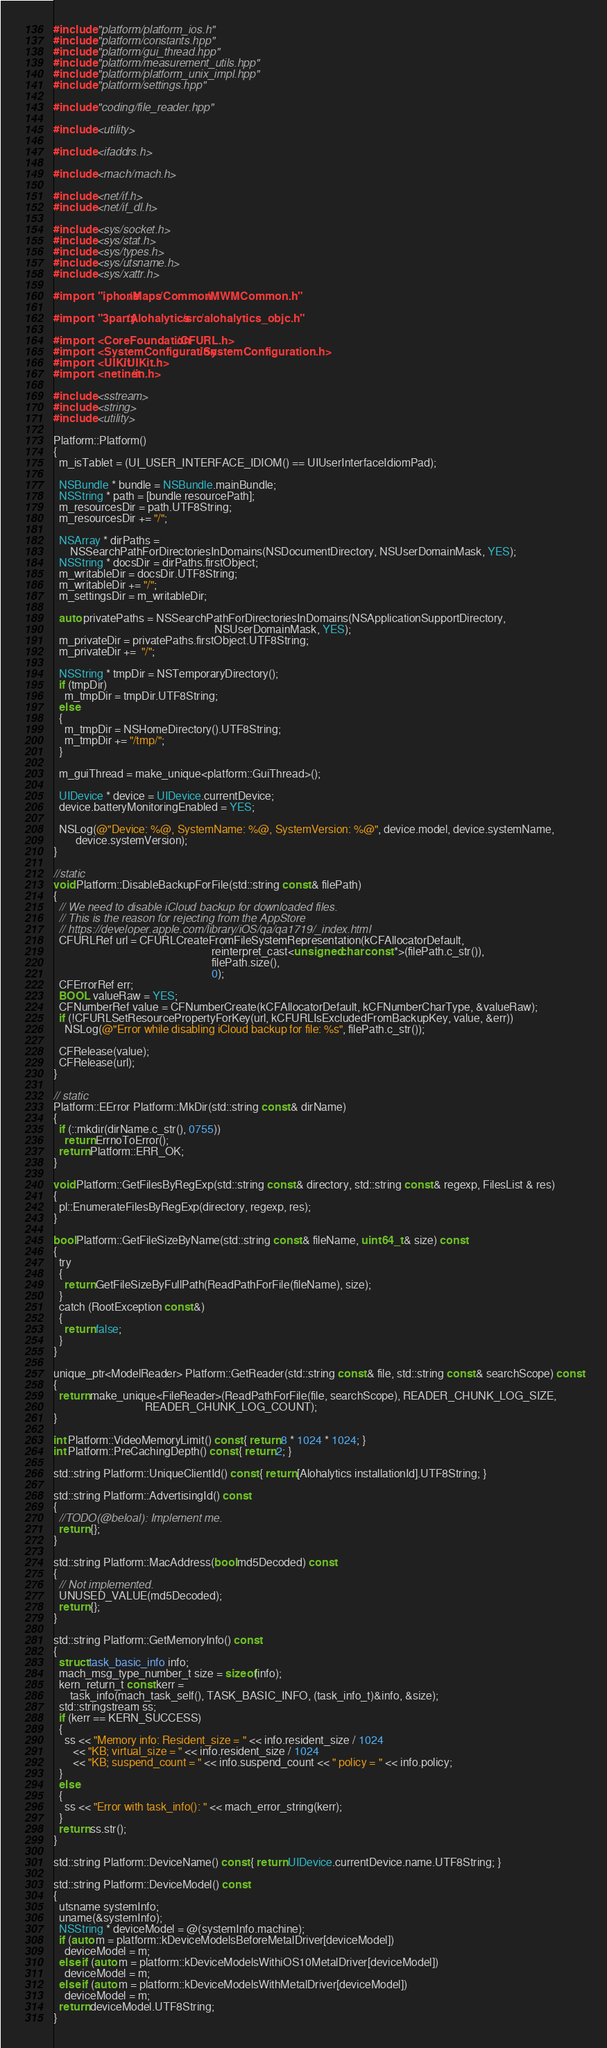Convert code to text. <code><loc_0><loc_0><loc_500><loc_500><_ObjectiveC_>#include "platform/platform_ios.h"
#include "platform/constants.hpp"
#include "platform/gui_thread.hpp"
#include "platform/measurement_utils.hpp"
#include "platform/platform_unix_impl.hpp"
#include "platform/settings.hpp"

#include "coding/file_reader.hpp"

#include <utility>

#include <ifaddrs.h>

#include <mach/mach.h>

#include <net/if.h>
#include <net/if_dl.h>

#include <sys/socket.h>
#include <sys/stat.h>
#include <sys/types.h>
#include <sys/utsname.h>
#include <sys/xattr.h>

#import "iphone/Maps/Common/MWMCommon.h"

#import "3party/Alohalytics/src/alohalytics_objc.h"

#import <CoreFoundation/CFURL.h>
#import <SystemConfiguration/SystemConfiguration.h>
#import <UIKit/UIKit.h>
#import <netinet/in.h>

#include <sstream>
#include <string>
#include <utility>

Platform::Platform()
{
  m_isTablet = (UI_USER_INTERFACE_IDIOM() == UIUserInterfaceIdiomPad);

  NSBundle * bundle = NSBundle.mainBundle;
  NSString * path = [bundle resourcePath];
  m_resourcesDir = path.UTF8String;
  m_resourcesDir += "/";

  NSArray * dirPaths =
      NSSearchPathForDirectoriesInDomains(NSDocumentDirectory, NSUserDomainMask, YES);
  NSString * docsDir = dirPaths.firstObject;
  m_writableDir = docsDir.UTF8String;
  m_writableDir += "/";
  m_settingsDir = m_writableDir;

  auto privatePaths = NSSearchPathForDirectoriesInDomains(NSApplicationSupportDirectory,
                                                          NSUserDomainMask, YES);
  m_privateDir = privatePaths.firstObject.UTF8String;
  m_privateDir +=  "/";

  NSString * tmpDir = NSTemporaryDirectory();
  if (tmpDir)
    m_tmpDir = tmpDir.UTF8String;
  else
  {
    m_tmpDir = NSHomeDirectory().UTF8String;
    m_tmpDir += "/tmp/";
  }

  m_guiThread = make_unique<platform::GuiThread>();

  UIDevice * device = UIDevice.currentDevice;
  device.batteryMonitoringEnabled = YES;

  NSLog(@"Device: %@, SystemName: %@, SystemVersion: %@", device.model, device.systemName,
        device.systemVersion);
}

//static
void Platform::DisableBackupForFile(std::string const & filePath)
{
  // We need to disable iCloud backup for downloaded files.
  // This is the reason for rejecting from the AppStore
  // https://developer.apple.com/library/iOS/qa/qa1719/_index.html
  CFURLRef url = CFURLCreateFromFileSystemRepresentation(kCFAllocatorDefault,
                                                         reinterpret_cast<unsigned char const *>(filePath.c_str()),
                                                         filePath.size(),
                                                         0);
  CFErrorRef err;
  BOOL valueRaw = YES;
  CFNumberRef value = CFNumberCreate(kCFAllocatorDefault, kCFNumberCharType, &valueRaw);
  if (!CFURLSetResourcePropertyForKey(url, kCFURLIsExcludedFromBackupKey, value, &err))
    NSLog(@"Error while disabling iCloud backup for file: %s", filePath.c_str());

  CFRelease(value);
  CFRelease(url);
}

// static
Platform::EError Platform::MkDir(std::string const & dirName)
{
  if (::mkdir(dirName.c_str(), 0755))
    return ErrnoToError();
  return Platform::ERR_OK;
}

void Platform::GetFilesByRegExp(std::string const & directory, std::string const & regexp, FilesList & res)
{
  pl::EnumerateFilesByRegExp(directory, regexp, res);
}

bool Platform::GetFileSizeByName(std::string const & fileName, uint64_t & size) const
{
  try
  {
    return GetFileSizeByFullPath(ReadPathForFile(fileName), size);
  }
  catch (RootException const &)
  {
    return false;
  }
}

unique_ptr<ModelReader> Platform::GetReader(std::string const & file, std::string const & searchScope) const
{
  return make_unique<FileReader>(ReadPathForFile(file, searchScope), READER_CHUNK_LOG_SIZE,
                                 READER_CHUNK_LOG_COUNT);
}

int Platform::VideoMemoryLimit() const { return 8 * 1024 * 1024; }
int Platform::PreCachingDepth() const { return 2; }

std::string Platform::UniqueClientId() const { return [Alohalytics installationId].UTF8String; }

std::string Platform::AdvertisingId() const
{
  //TODO(@beloal): Implement me.
  return {};
}

std::string Platform::MacAddress(bool md5Decoded) const
{
  // Not implemented.
  UNUSED_VALUE(md5Decoded);
  return {};
}

std::string Platform::GetMemoryInfo() const
{
  struct task_basic_info info;
  mach_msg_type_number_t size = sizeof(info);
  kern_return_t const kerr =
      task_info(mach_task_self(), TASK_BASIC_INFO, (task_info_t)&info, &size);
  std::stringstream ss;
  if (kerr == KERN_SUCCESS)
  {
    ss << "Memory info: Resident_size = " << info.resident_size / 1024
       << "KB; virtual_size = " << info.resident_size / 1024
       << "KB; suspend_count = " << info.suspend_count << " policy = " << info.policy;
  }
  else
  {
    ss << "Error with task_info(): " << mach_error_string(kerr);
  }
  return ss.str();
}

std::string Platform::DeviceName() const { return UIDevice.currentDevice.name.UTF8String; }

std::string Platform::DeviceModel() const
{
  utsname systemInfo;
  uname(&systemInfo);
  NSString * deviceModel = @(systemInfo.machine);
  if (auto m = platform::kDeviceModelsBeforeMetalDriver[deviceModel])
    deviceModel = m;
  else if (auto m = platform::kDeviceModelsWithiOS10MetalDriver[deviceModel])
    deviceModel = m;
  else if (auto m = platform::kDeviceModelsWithMetalDriver[deviceModel])
    deviceModel = m;
  return deviceModel.UTF8String;
}
</code> 